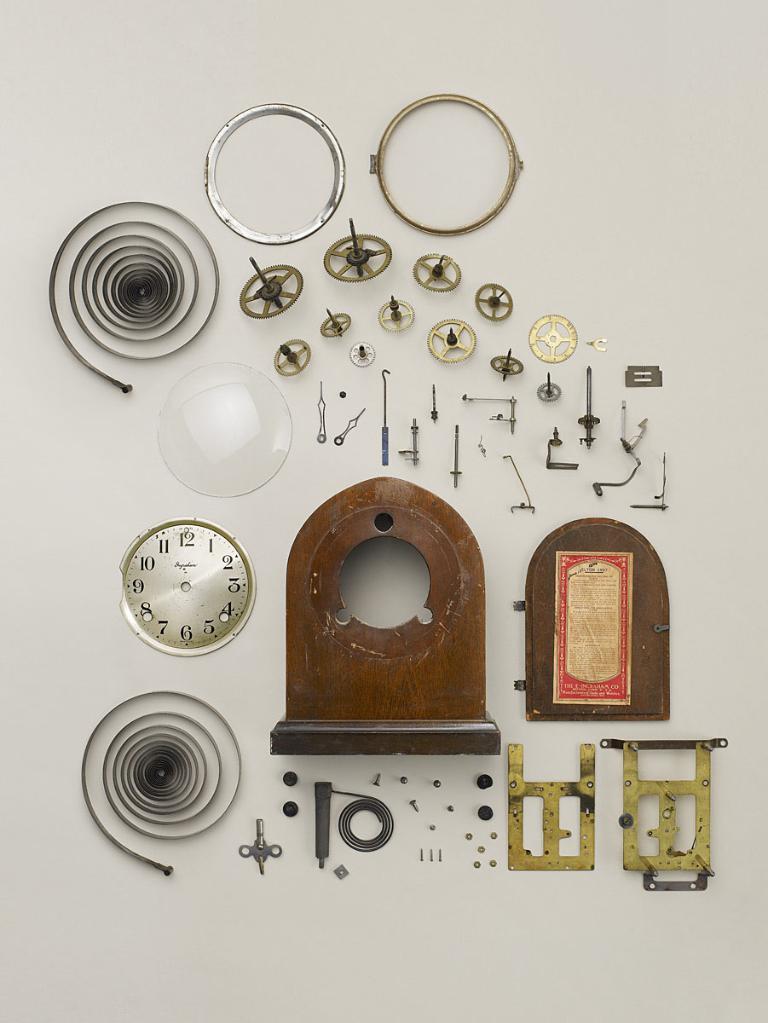In one or two sentences, can you explain what this image depicts? In this image, we can see spare parts of a clock on white background. 